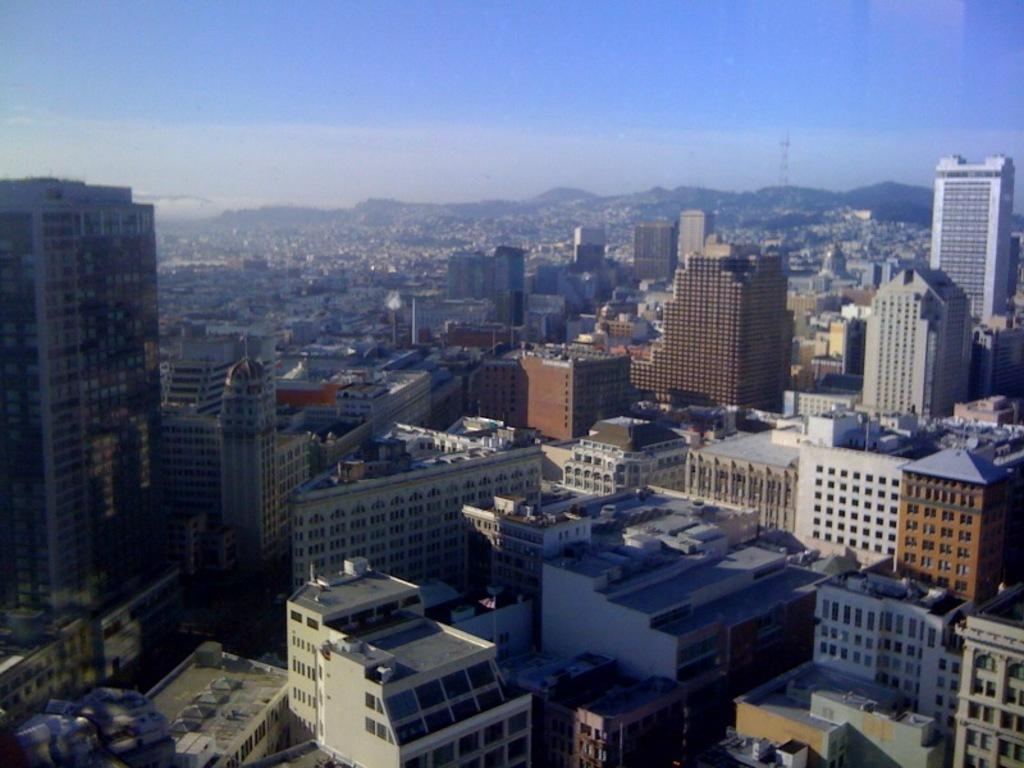What can be seen in the sky in the image? The sky is visible in the image. What type of natural landscape is present in the image? There are hills in the image. What type of man-made structures can be seen in the image? There are buildings and towers in the image. What type of transportation is present in the image? Motor vehicles are present in the image. Are there any giants visible in the image? No, there are no giants present in the image. Is there a cemetery located on one of the hills in the image? There is no information about a cemetery in the image; it only shows hills, buildings, towers, and motor vehicles. 